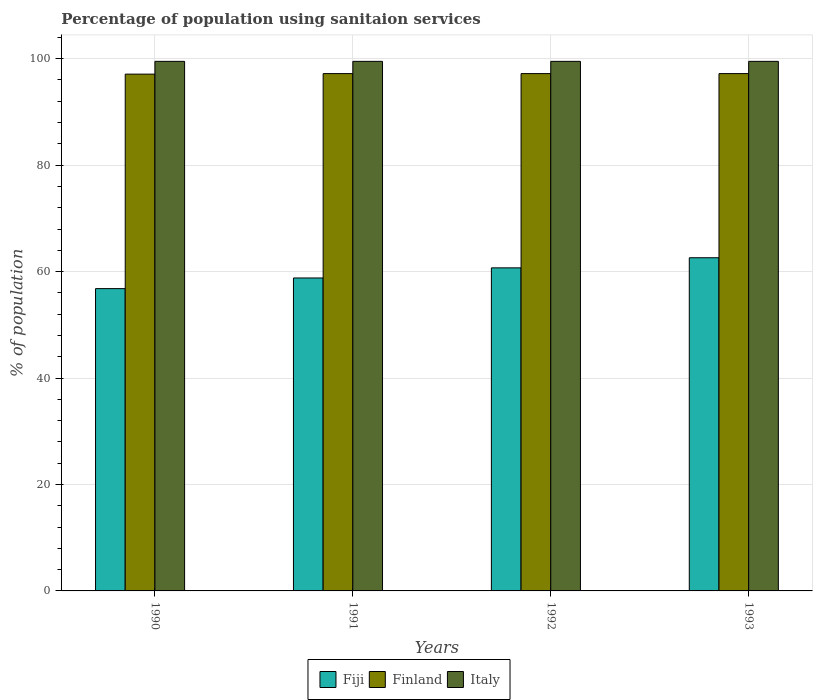How many groups of bars are there?
Ensure brevity in your answer.  4. How many bars are there on the 3rd tick from the left?
Your answer should be very brief. 3. What is the label of the 4th group of bars from the left?
Your response must be concise. 1993. In how many cases, is the number of bars for a given year not equal to the number of legend labels?
Make the answer very short. 0. What is the percentage of population using sanitaion services in Finland in 1991?
Offer a very short reply. 97.2. Across all years, what is the maximum percentage of population using sanitaion services in Italy?
Offer a very short reply. 99.5. Across all years, what is the minimum percentage of population using sanitaion services in Italy?
Make the answer very short. 99.5. In which year was the percentage of population using sanitaion services in Finland minimum?
Your response must be concise. 1990. What is the total percentage of population using sanitaion services in Italy in the graph?
Offer a very short reply. 398. What is the difference between the percentage of population using sanitaion services in Finland in 1990 and that in 1992?
Keep it short and to the point. -0.1. What is the difference between the percentage of population using sanitaion services in Finland in 1993 and the percentage of population using sanitaion services in Fiji in 1991?
Offer a very short reply. 38.4. What is the average percentage of population using sanitaion services in Finland per year?
Give a very brief answer. 97.17. In the year 1991, what is the difference between the percentage of population using sanitaion services in Fiji and percentage of population using sanitaion services in Finland?
Give a very brief answer. -38.4. What is the ratio of the percentage of population using sanitaion services in Finland in 1991 to that in 1992?
Your response must be concise. 1. Is the percentage of population using sanitaion services in Finland in 1992 less than that in 1993?
Offer a very short reply. No. What is the difference between the highest and the second highest percentage of population using sanitaion services in Fiji?
Offer a terse response. 1.9. What is the difference between the highest and the lowest percentage of population using sanitaion services in Finland?
Your answer should be compact. 0.1. In how many years, is the percentage of population using sanitaion services in Fiji greater than the average percentage of population using sanitaion services in Fiji taken over all years?
Provide a short and direct response. 2. Is the sum of the percentage of population using sanitaion services in Fiji in 1990 and 1991 greater than the maximum percentage of population using sanitaion services in Finland across all years?
Your answer should be compact. Yes. What does the 1st bar from the left in 1990 represents?
Offer a terse response. Fiji. Is it the case that in every year, the sum of the percentage of population using sanitaion services in Italy and percentage of population using sanitaion services in Fiji is greater than the percentage of population using sanitaion services in Finland?
Provide a succinct answer. Yes. How many bars are there?
Your response must be concise. 12. Are the values on the major ticks of Y-axis written in scientific E-notation?
Keep it short and to the point. No. Does the graph contain grids?
Ensure brevity in your answer.  Yes. Where does the legend appear in the graph?
Offer a very short reply. Bottom center. How many legend labels are there?
Offer a terse response. 3. What is the title of the graph?
Offer a very short reply. Percentage of population using sanitaion services. Does "Caribbean small states" appear as one of the legend labels in the graph?
Ensure brevity in your answer.  No. What is the label or title of the Y-axis?
Give a very brief answer. % of population. What is the % of population of Fiji in 1990?
Your answer should be very brief. 56.8. What is the % of population of Finland in 1990?
Your answer should be very brief. 97.1. What is the % of population of Italy in 1990?
Keep it short and to the point. 99.5. What is the % of population in Fiji in 1991?
Ensure brevity in your answer.  58.8. What is the % of population in Finland in 1991?
Provide a succinct answer. 97.2. What is the % of population of Italy in 1991?
Offer a very short reply. 99.5. What is the % of population of Fiji in 1992?
Give a very brief answer. 60.7. What is the % of population of Finland in 1992?
Keep it short and to the point. 97.2. What is the % of population of Italy in 1992?
Give a very brief answer. 99.5. What is the % of population of Fiji in 1993?
Ensure brevity in your answer.  62.6. What is the % of population in Finland in 1993?
Provide a succinct answer. 97.2. What is the % of population in Italy in 1993?
Provide a short and direct response. 99.5. Across all years, what is the maximum % of population of Fiji?
Ensure brevity in your answer.  62.6. Across all years, what is the maximum % of population of Finland?
Your answer should be compact. 97.2. Across all years, what is the maximum % of population in Italy?
Your answer should be compact. 99.5. Across all years, what is the minimum % of population in Fiji?
Your answer should be very brief. 56.8. Across all years, what is the minimum % of population of Finland?
Offer a very short reply. 97.1. Across all years, what is the minimum % of population of Italy?
Provide a short and direct response. 99.5. What is the total % of population in Fiji in the graph?
Provide a succinct answer. 238.9. What is the total % of population of Finland in the graph?
Make the answer very short. 388.7. What is the total % of population in Italy in the graph?
Provide a succinct answer. 398. What is the difference between the % of population in Fiji in 1990 and that in 1991?
Your response must be concise. -2. What is the difference between the % of population of Fiji in 1990 and that in 1992?
Give a very brief answer. -3.9. What is the difference between the % of population of Finland in 1990 and that in 1992?
Offer a very short reply. -0.1. What is the difference between the % of population in Italy in 1990 and that in 1992?
Offer a terse response. 0. What is the difference between the % of population in Fiji in 1990 and that in 1993?
Provide a short and direct response. -5.8. What is the difference between the % of population in Italy in 1990 and that in 1993?
Keep it short and to the point. 0. What is the difference between the % of population of Fiji in 1991 and that in 1992?
Your answer should be compact. -1.9. What is the difference between the % of population in Italy in 1991 and that in 1992?
Make the answer very short. 0. What is the difference between the % of population of Fiji in 1991 and that in 1993?
Ensure brevity in your answer.  -3.8. What is the difference between the % of population in Italy in 1991 and that in 1993?
Make the answer very short. 0. What is the difference between the % of population of Fiji in 1992 and that in 1993?
Offer a very short reply. -1.9. What is the difference between the % of population in Finland in 1992 and that in 1993?
Make the answer very short. 0. What is the difference between the % of population of Fiji in 1990 and the % of population of Finland in 1991?
Make the answer very short. -40.4. What is the difference between the % of population in Fiji in 1990 and the % of population in Italy in 1991?
Make the answer very short. -42.7. What is the difference between the % of population of Fiji in 1990 and the % of population of Finland in 1992?
Your answer should be compact. -40.4. What is the difference between the % of population of Fiji in 1990 and the % of population of Italy in 1992?
Your response must be concise. -42.7. What is the difference between the % of population in Finland in 1990 and the % of population in Italy in 1992?
Offer a very short reply. -2.4. What is the difference between the % of population of Fiji in 1990 and the % of population of Finland in 1993?
Your answer should be compact. -40.4. What is the difference between the % of population in Fiji in 1990 and the % of population in Italy in 1993?
Make the answer very short. -42.7. What is the difference between the % of population in Fiji in 1991 and the % of population in Finland in 1992?
Offer a very short reply. -38.4. What is the difference between the % of population in Fiji in 1991 and the % of population in Italy in 1992?
Offer a terse response. -40.7. What is the difference between the % of population of Finland in 1991 and the % of population of Italy in 1992?
Make the answer very short. -2.3. What is the difference between the % of population of Fiji in 1991 and the % of population of Finland in 1993?
Your answer should be compact. -38.4. What is the difference between the % of population of Fiji in 1991 and the % of population of Italy in 1993?
Make the answer very short. -40.7. What is the difference between the % of population in Finland in 1991 and the % of population in Italy in 1993?
Make the answer very short. -2.3. What is the difference between the % of population in Fiji in 1992 and the % of population in Finland in 1993?
Provide a short and direct response. -36.5. What is the difference between the % of population in Fiji in 1992 and the % of population in Italy in 1993?
Provide a succinct answer. -38.8. What is the average % of population in Fiji per year?
Ensure brevity in your answer.  59.73. What is the average % of population of Finland per year?
Your answer should be very brief. 97.17. What is the average % of population in Italy per year?
Your answer should be very brief. 99.5. In the year 1990, what is the difference between the % of population of Fiji and % of population of Finland?
Your answer should be compact. -40.3. In the year 1990, what is the difference between the % of population of Fiji and % of population of Italy?
Make the answer very short. -42.7. In the year 1991, what is the difference between the % of population in Fiji and % of population in Finland?
Keep it short and to the point. -38.4. In the year 1991, what is the difference between the % of population in Fiji and % of population in Italy?
Give a very brief answer. -40.7. In the year 1991, what is the difference between the % of population of Finland and % of population of Italy?
Make the answer very short. -2.3. In the year 1992, what is the difference between the % of population in Fiji and % of population in Finland?
Give a very brief answer. -36.5. In the year 1992, what is the difference between the % of population in Fiji and % of population in Italy?
Provide a succinct answer. -38.8. In the year 1992, what is the difference between the % of population in Finland and % of population in Italy?
Ensure brevity in your answer.  -2.3. In the year 1993, what is the difference between the % of population of Fiji and % of population of Finland?
Offer a terse response. -34.6. In the year 1993, what is the difference between the % of population of Fiji and % of population of Italy?
Make the answer very short. -36.9. In the year 1993, what is the difference between the % of population of Finland and % of population of Italy?
Keep it short and to the point. -2.3. What is the ratio of the % of population of Fiji in 1990 to that in 1992?
Give a very brief answer. 0.94. What is the ratio of the % of population in Finland in 1990 to that in 1992?
Offer a terse response. 1. What is the ratio of the % of population of Fiji in 1990 to that in 1993?
Your answer should be compact. 0.91. What is the ratio of the % of population in Fiji in 1991 to that in 1992?
Offer a very short reply. 0.97. What is the ratio of the % of population of Fiji in 1991 to that in 1993?
Your answer should be very brief. 0.94. What is the ratio of the % of population of Italy in 1991 to that in 1993?
Give a very brief answer. 1. What is the ratio of the % of population of Fiji in 1992 to that in 1993?
Make the answer very short. 0.97. What is the ratio of the % of population of Italy in 1992 to that in 1993?
Give a very brief answer. 1. What is the difference between the highest and the second highest % of population of Italy?
Provide a short and direct response. 0. What is the difference between the highest and the lowest % of population of Finland?
Provide a short and direct response. 0.1. 